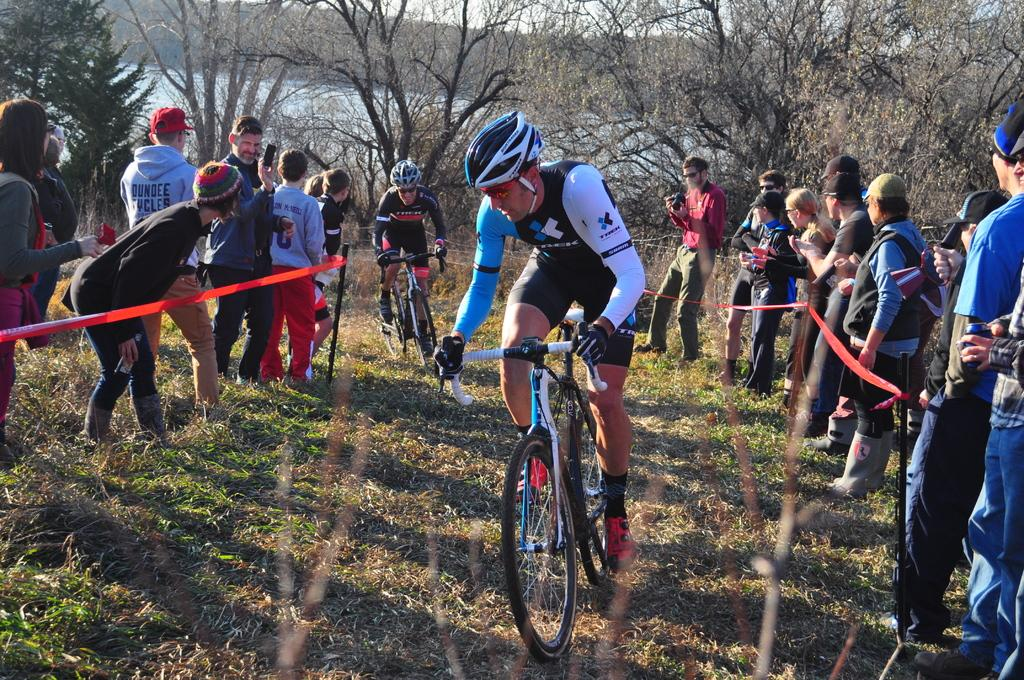What are the main subjects in the center of the image? There are persons riding bicycles in the center of the image. What can be seen on the right side of the image? There are persons on the right side of the image. What is visible on the left side of the image? There are persons on the left side of the image. What type of natural environment is visible in the background of the image? There are trees, water, and the sky visible in the background of the image. How many women are present in the image? The provided facts do not specify the gender of the persons in the image, so it is impossible to determine the number of women present. 